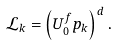<formula> <loc_0><loc_0><loc_500><loc_500>\mathcal { L } _ { k } = \left ( U ^ { f } _ { 0 } p _ { k } \right ) ^ { d } .</formula> 